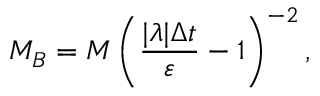<formula> <loc_0><loc_0><loc_500><loc_500>M _ { B } = M \left ( \frac { | \lambda | \Delta t } { \varepsilon } - 1 \right ) ^ { - 2 } ,</formula> 